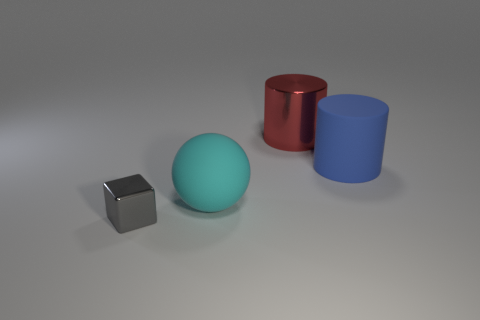There is another cylinder that is the same size as the red metal cylinder; what material is it?
Keep it short and to the point. Rubber. What is the color of the thing that is both to the left of the red metallic cylinder and behind the tiny metallic object?
Give a very brief answer. Cyan. What number of spheres are gray metal objects or red objects?
Ensure brevity in your answer.  0. Is the number of big rubber things that are left of the matte sphere less than the number of yellow things?
Your response must be concise. No. The other tiny thing that is the same material as the red object is what shape?
Your response must be concise. Cube. What number of objects are tiny purple matte blocks or gray things?
Give a very brief answer. 1. There is a object to the left of the rubber object that is in front of the rubber cylinder; what is it made of?
Make the answer very short. Metal. Are there any purple balls made of the same material as the gray cube?
Your answer should be very brief. No. There is a metal thing in front of the cylinder that is to the left of the large matte thing that is right of the metal cylinder; what is its shape?
Your answer should be compact. Cube. What material is the large blue cylinder?
Your answer should be very brief. Rubber. 